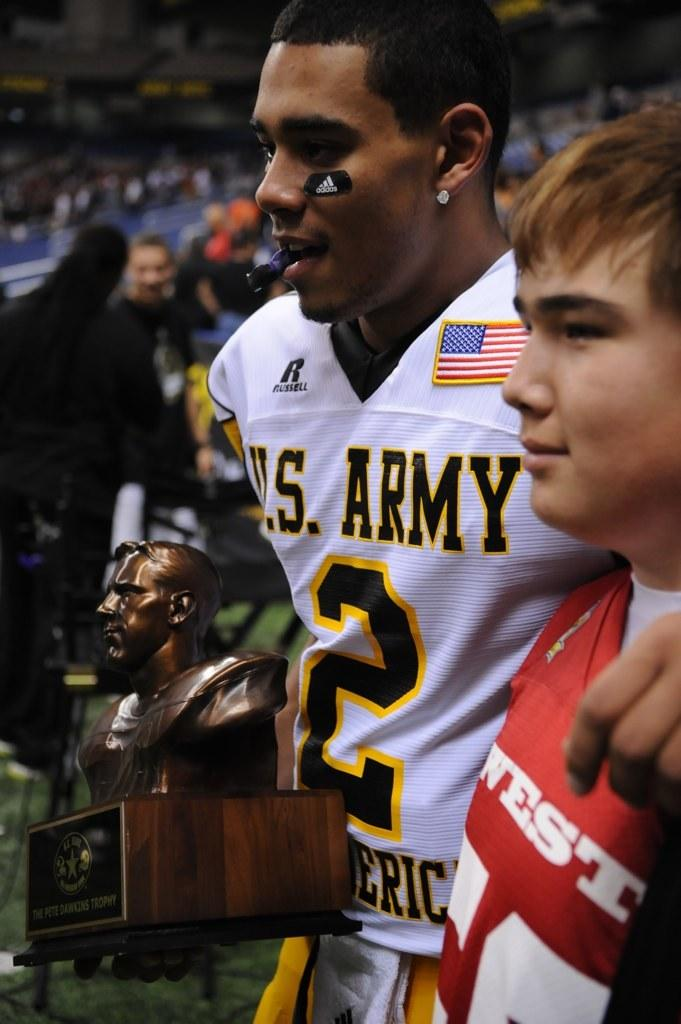<image>
Share a concise interpretation of the image provided. a football player for the US army holding a trophy 